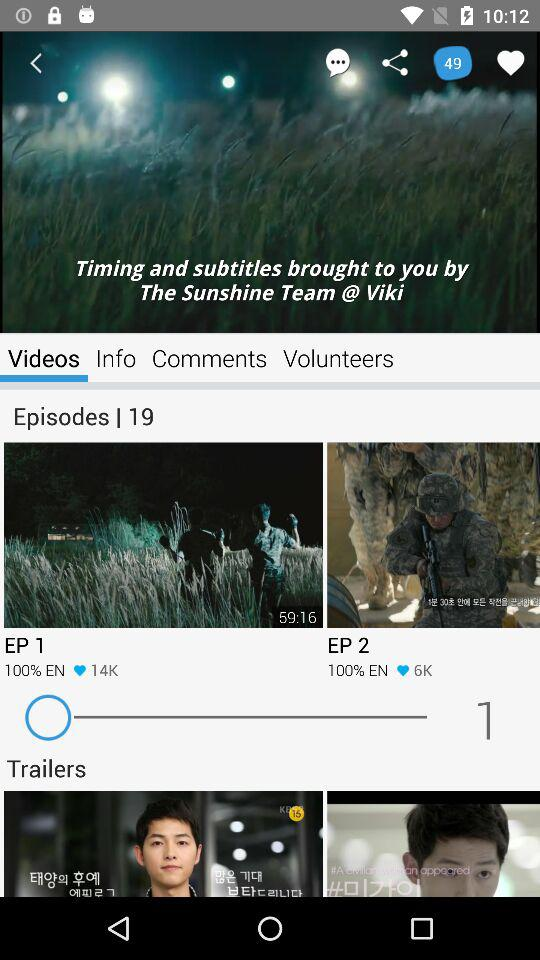How many more hearts does the first episode have than the second episode?
Answer the question using a single word or phrase. 8000 